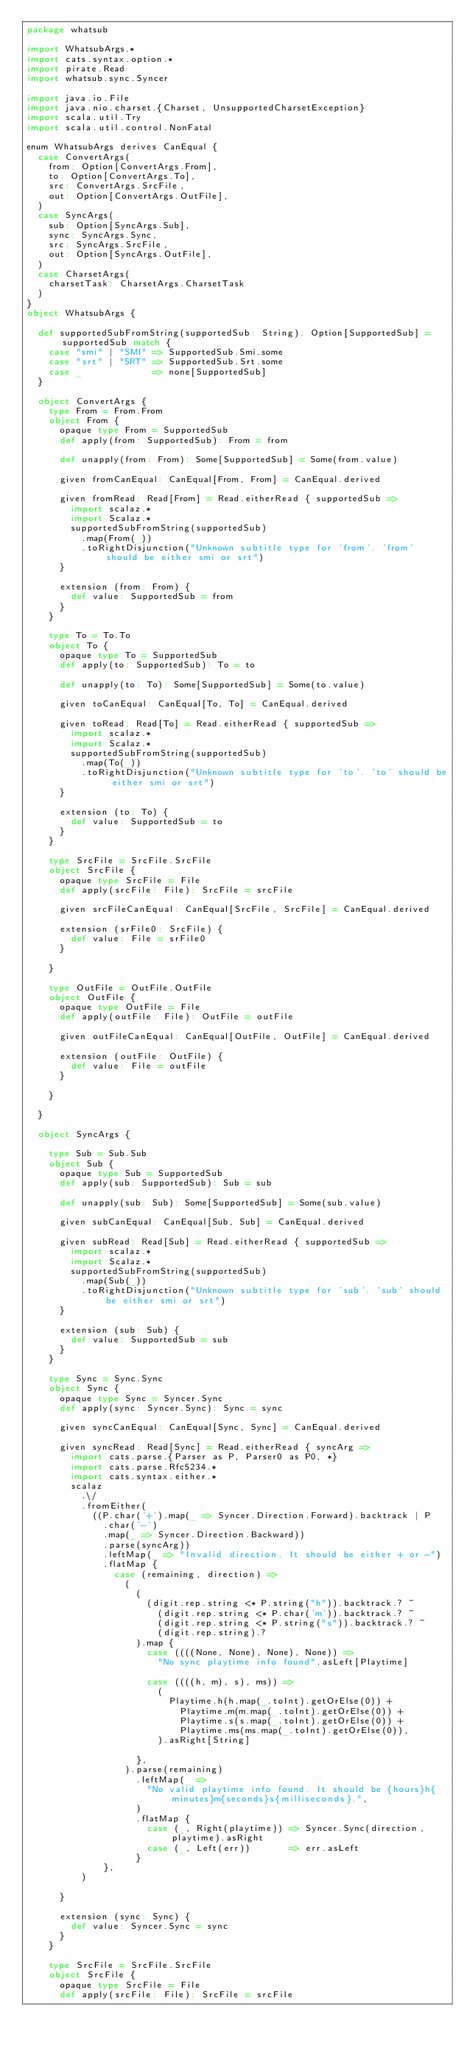Convert code to text. <code><loc_0><loc_0><loc_500><loc_500><_Scala_>package whatsub

import WhatsubArgs.*
import cats.syntax.option.*
import pirate.Read
import whatsub.sync.Syncer

import java.io.File
import java.nio.charset.{Charset, UnsupportedCharsetException}
import scala.util.Try
import scala.util.control.NonFatal

enum WhatsubArgs derives CanEqual {
  case ConvertArgs(
    from: Option[ConvertArgs.From],
    to: Option[ConvertArgs.To],
    src: ConvertArgs.SrcFile,
    out: Option[ConvertArgs.OutFile],
  )
  case SyncArgs(
    sub: Option[SyncArgs.Sub],
    sync: SyncArgs.Sync,
    src: SyncArgs.SrcFile,
    out: Option[SyncArgs.OutFile],
  )
  case CharsetArgs(
    charsetTask: CharsetArgs.CharsetTask
  )
}
object WhatsubArgs {

  def supportedSubFromString(supportedSub: String): Option[SupportedSub] = supportedSub match {
    case "smi" | "SMI" => SupportedSub.Smi.some
    case "srt" | "SRT" => SupportedSub.Srt.some
    case _             => none[SupportedSub]
  }

  object ConvertArgs {
    type From = From.From
    object From {
      opaque type From = SupportedSub
      def apply(from: SupportedSub): From = from

      def unapply(from: From): Some[SupportedSub] = Some(from.value)

      given fromCanEqual: CanEqual[From, From] = CanEqual.derived

      given fromRead: Read[From] = Read.eitherRead { supportedSub =>
        import scalaz.*
        import Scalaz.*
        supportedSubFromString(supportedSub)
          .map(From(_))
          .toRightDisjunction("Unknown subtitle type for 'from'. 'from' should be either smi or srt")
      }

      extension (from: From) {
        def value: SupportedSub = from
      }
    }

    type To = To.To
    object To {
      opaque type To = SupportedSub
      def apply(to: SupportedSub): To = to

      def unapply(to: To): Some[SupportedSub] = Some(to.value)

      given toCanEqual: CanEqual[To, To] = CanEqual.derived

      given toRead: Read[To] = Read.eitherRead { supportedSub =>
        import scalaz.*
        import Scalaz.*
        supportedSubFromString(supportedSub)
          .map(To(_))
          .toRightDisjunction("Unknown subtitle type for 'to'. 'to' should be either smi or srt")
      }

      extension (to: To) {
        def value: SupportedSub = to
      }
    }

    type SrcFile = SrcFile.SrcFile
    object SrcFile {
      opaque type SrcFile = File
      def apply(srcFile: File): SrcFile = srcFile

      given srcFileCanEqual: CanEqual[SrcFile, SrcFile] = CanEqual.derived

      extension (srFile0: SrcFile) {
        def value: File = srFile0
      }

    }

    type OutFile = OutFile.OutFile
    object OutFile {
      opaque type OutFile = File
      def apply(outFile: File): OutFile = outFile

      given outFileCanEqual: CanEqual[OutFile, OutFile] = CanEqual.derived

      extension (outFile: OutFile) {
        def value: File = outFile
      }

    }

  }

  object SyncArgs {

    type Sub = Sub.Sub
    object Sub {
      opaque type Sub = SupportedSub
      def apply(sub: SupportedSub): Sub = sub

      def unapply(sub: Sub): Some[SupportedSub] = Some(sub.value)

      given subCanEqual: CanEqual[Sub, Sub] = CanEqual.derived

      given subRead: Read[Sub] = Read.eitherRead { supportedSub =>
        import scalaz.*
        import Scalaz.*
        supportedSubFromString(supportedSub)
          .map(Sub(_))
          .toRightDisjunction("Unknown subtitle type for 'sub'. 'sub' should be either smi or srt")
      }

      extension (sub: Sub) {
        def value: SupportedSub = sub
      }
    }

    type Sync = Sync.Sync
    object Sync {
      opaque type Sync = Syncer.Sync
      def apply(sync: Syncer.Sync): Sync = sync

      given syncCanEqual: CanEqual[Sync, Sync] = CanEqual.derived

      given syncRead: Read[Sync] = Read.eitherRead { syncArg =>
        import cats.parse.{Parser as P, Parser0 as P0, *}
        import cats.parse.Rfc5234.*
        import cats.syntax.either.*
        scalaz
          .\/
          .fromEither(
            ((P.char('+').map(_ => Syncer.Direction.Forward).backtrack | P
              .char('-')
              .map(_ => Syncer.Direction.Backward))
              .parse(syncArg))
              .leftMap(_ => "Invalid direction. It should be either + or -")
              .flatMap {
                case (remaining, direction) =>
                  (
                    (
                      (digit.rep.string <* P.string("h")).backtrack.? ~
                        (digit.rep.string <* P.char('m')).backtrack.? ~
                        (digit.rep.string <* P.string("s")).backtrack.? ~
                        (digit.rep.string).?
                    ).map {
                      case ((((None, None), None), None)) =>
                        "No sync playtime info found".asLeft[Playtime]

                      case ((((h, m), s), ms)) =>
                        (
                          Playtime.h(h.map(_.toInt).getOrElse(0)) +
                            Playtime.m(m.map(_.toInt).getOrElse(0)) +
                            Playtime.s(s.map(_.toInt).getOrElse(0)) +
                            Playtime.ms(ms.map(_.toInt).getOrElse(0)),
                        ).asRight[String]

                    },
                  ).parse(remaining)
                    .leftMap(_ =>
                      "No valid playtime info found. It should be {hours}h{minutes}m{seconds}s{milliseconds}.",
                    )
                    .flatMap {
                      case (_, Right(playtime)) => Syncer.Sync(direction, playtime).asRight
                      case (_, Left(err))       => err.asLeft
                    }
              },
          )

      }

      extension (sync: Sync) {
        def value: Syncer.Sync = sync
      }
    }

    type SrcFile = SrcFile.SrcFile
    object SrcFile {
      opaque type SrcFile = File
      def apply(srcFile: File): SrcFile = srcFile
</code> 